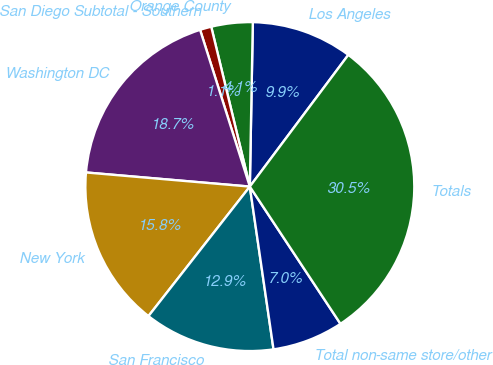<chart> <loc_0><loc_0><loc_500><loc_500><pie_chart><fcel>Los Angeles<fcel>Orange County<fcel>San Diego Subtotal - Southern<fcel>Washington DC<fcel>New York<fcel>San Francisco<fcel>Total non-same store/other<fcel>Totals<nl><fcel>9.93%<fcel>4.06%<fcel>1.12%<fcel>18.74%<fcel>15.8%<fcel>12.87%<fcel>6.99%<fcel>30.49%<nl></chart> 